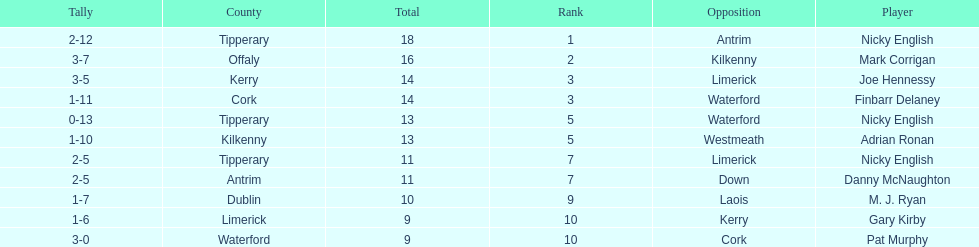If you added all the total's up, what would the number be? 138. 